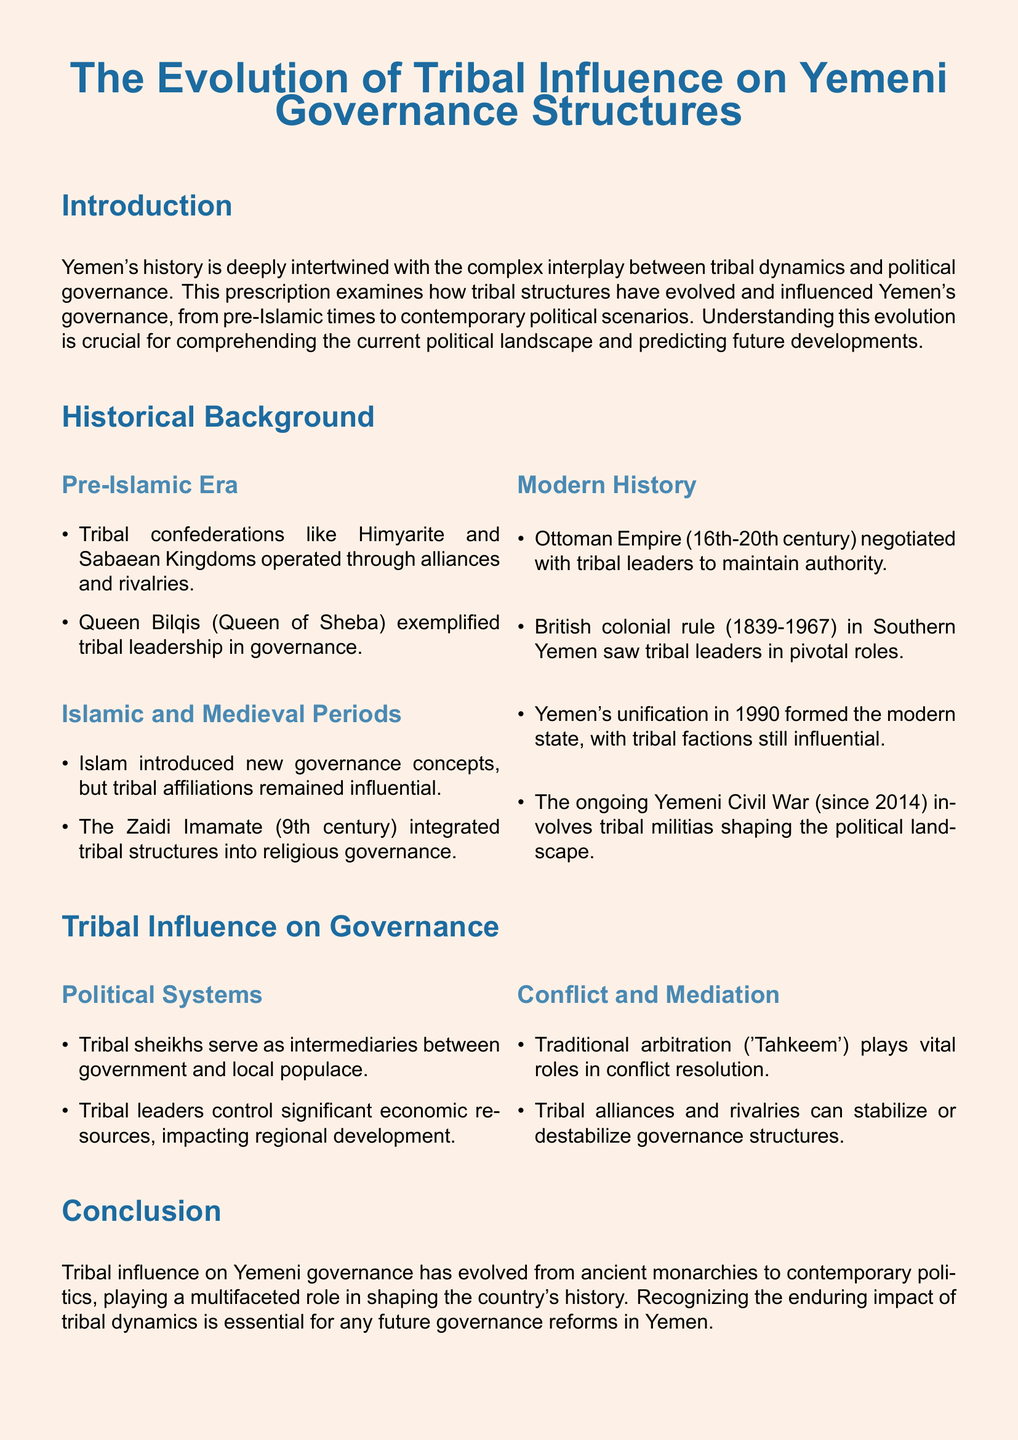What was the main role of Queen Bilqis in pre-Islamic governance? Queen Bilqis exemplified tribal leadership in governance.
Answer: Tribal leadership What century did the Zaidi Imamate begin integrating tribal structures? The Zaidi Imamate began integrating tribal structures in the 9th century.
Answer: 9th century How long did British colonial rule last in Southern Yemen? British colonial rule lasted from 1839 to 1967.
Answer: 128 years What concept did Islam introduce to Yemeni governance? Islam introduced new governance concepts.
Answer: New governance concepts How do tribal sheikhs function within the government? Tribal sheikhs serve as intermediaries between government and local populace.
Answer: Intermediaries What does 'Tahkeem' refer to in the context of tribal influence? Traditional arbitration in conflict resolution is referred to as 'Tahkeem'.
Answer: Traditional arbitration Which event since 2014 significantly involved tribal militias in Yemen? The ongoing Yemeni Civil War significantly involved tribal militias.
Answer: Yemeni Civil War What are two roles of tribal leaders in regional governance? Tribal leaders control significant economic resources and mediate conflicts.
Answer: Economic control and conflict mediation What is essential for future governance reforms in Yemen? Recognizing the enduring impact of tribal dynamics is essential.
Answer: Enduring impact of tribal dynamics 